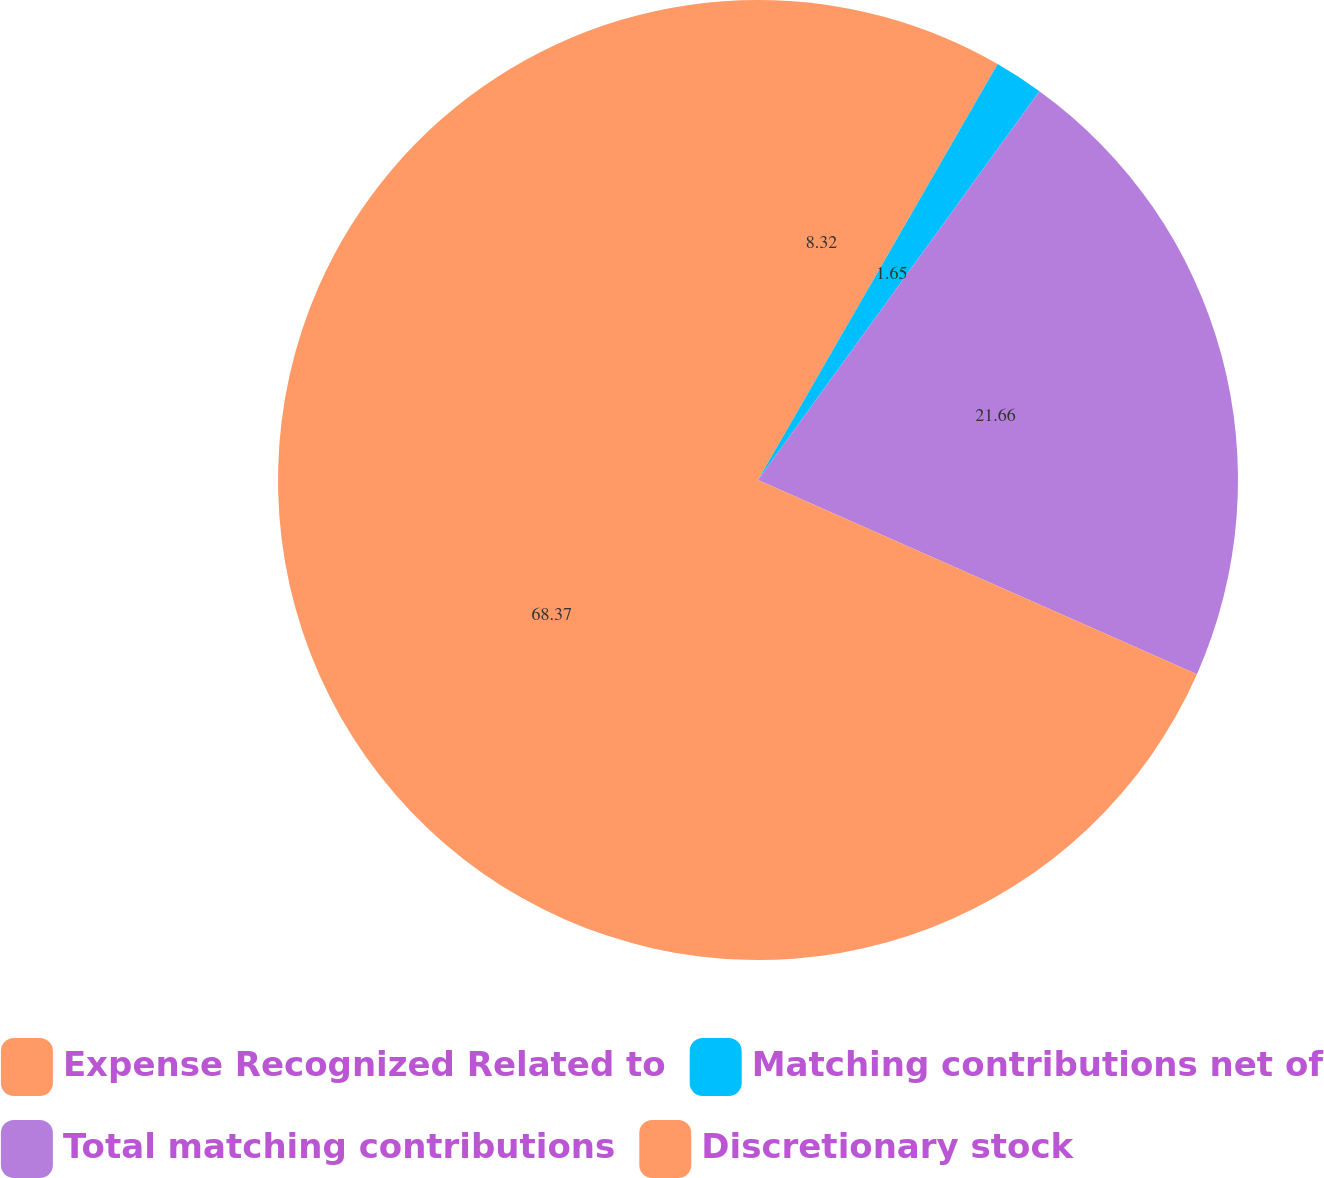<chart> <loc_0><loc_0><loc_500><loc_500><pie_chart><fcel>Expense Recognized Related to<fcel>Matching contributions net of<fcel>Total matching contributions<fcel>Discretionary stock<nl><fcel>8.32%<fcel>1.65%<fcel>21.66%<fcel>68.37%<nl></chart> 